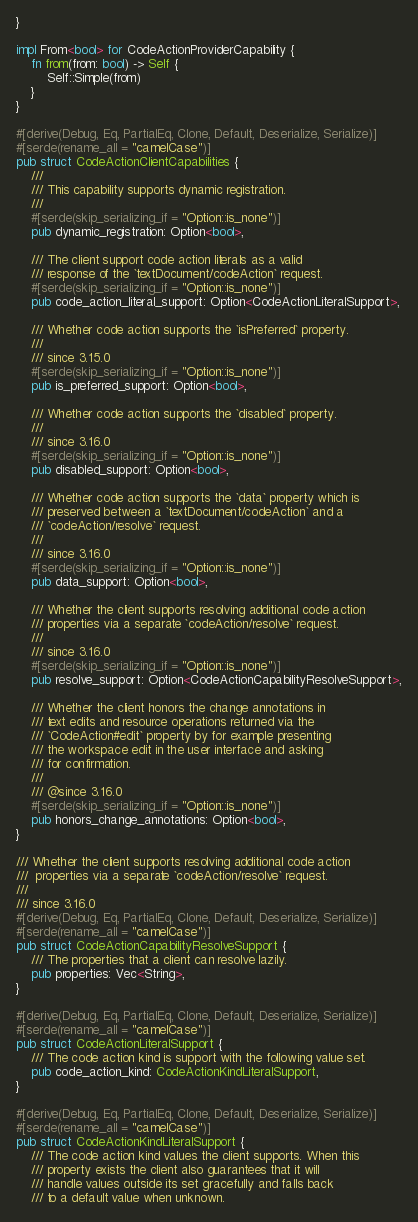<code> <loc_0><loc_0><loc_500><loc_500><_Rust_>}

impl From<bool> for CodeActionProviderCapability {
    fn from(from: bool) -> Self {
        Self::Simple(from)
    }
}

#[derive(Debug, Eq, PartialEq, Clone, Default, Deserialize, Serialize)]
#[serde(rename_all = "camelCase")]
pub struct CodeActionClientCapabilities {
    ///
    /// This capability supports dynamic registration.
    ///
    #[serde(skip_serializing_if = "Option::is_none")]
    pub dynamic_registration: Option<bool>,

    /// The client support code action literals as a valid
    /// response of the `textDocument/codeAction` request.
    #[serde(skip_serializing_if = "Option::is_none")]
    pub code_action_literal_support: Option<CodeActionLiteralSupport>,

    /// Whether code action supports the `isPreferred` property.
    ///
    /// since 3.15.0
    #[serde(skip_serializing_if = "Option::is_none")]
    pub is_preferred_support: Option<bool>,

    /// Whether code action supports the `disabled` property.
    ///
    /// since 3.16.0
    #[serde(skip_serializing_if = "Option::is_none")]
    pub disabled_support: Option<bool>,

    /// Whether code action supports the `data` property which is
    /// preserved between a `textDocument/codeAction` and a
    /// `codeAction/resolve` request.
    ///
    /// since 3.16.0
    #[serde(skip_serializing_if = "Option::is_none")]
    pub data_support: Option<bool>,

    /// Whether the client supports resolving additional code action
    /// properties via a separate `codeAction/resolve` request.
    ///
    /// since 3.16.0
    #[serde(skip_serializing_if = "Option::is_none")]
    pub resolve_support: Option<CodeActionCapabilityResolveSupport>,

    /// Whether the client honors the change annotations in
    /// text edits and resource operations returned via the
    /// `CodeAction#edit` property by for example presenting
    /// the workspace edit in the user interface and asking
    /// for confirmation.
    ///
    /// @since 3.16.0
    #[serde(skip_serializing_if = "Option::is_none")]
    pub honors_change_annotations: Option<bool>,
}

/// Whether the client supports resolving additional code action
///  properties via a separate `codeAction/resolve` request.
///
/// since 3.16.0
#[derive(Debug, Eq, PartialEq, Clone, Default, Deserialize, Serialize)]
#[serde(rename_all = "camelCase")]
pub struct CodeActionCapabilityResolveSupport {
    /// The properties that a client can resolve lazily.
    pub properties: Vec<String>,
}

#[derive(Debug, Eq, PartialEq, Clone, Default, Deserialize, Serialize)]
#[serde(rename_all = "camelCase")]
pub struct CodeActionLiteralSupport {
    /// The code action kind is support with the following value set.
    pub code_action_kind: CodeActionKindLiteralSupport,
}

#[derive(Debug, Eq, PartialEq, Clone, Default, Deserialize, Serialize)]
#[serde(rename_all = "camelCase")]
pub struct CodeActionKindLiteralSupport {
    /// The code action kind values the client supports. When this
    /// property exists the client also guarantees that it will
    /// handle values outside its set gracefully and falls back
    /// to a default value when unknown.</code> 